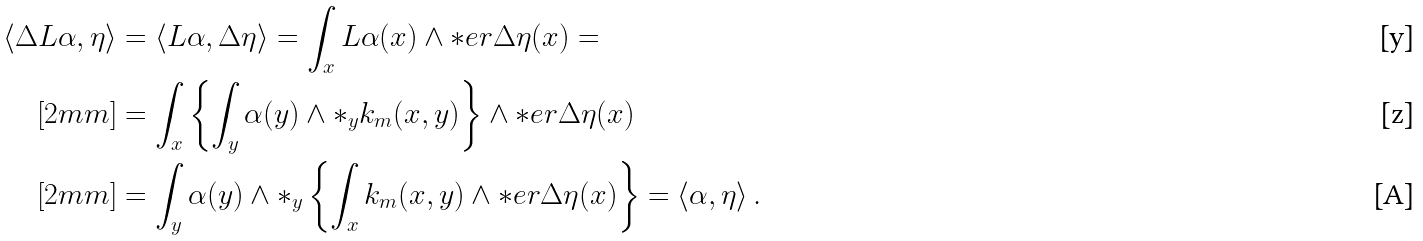<formula> <loc_0><loc_0><loc_500><loc_500>\langle \Delta L \alpha , \eta \rangle & = \langle L \alpha , \Delta \eta \rangle = \int _ { x } L \alpha ( x ) \wedge \ast e r \Delta \eta ( x ) = \\ [ 2 m m ] & = \int _ { x } \left \{ \int _ { y } \alpha ( y ) \wedge * _ { y } k _ { m } ( x , y ) \right \} \wedge \ast e r \Delta \eta ( x ) \\ [ 2 m m ] & = \int _ { y } \alpha ( y ) \wedge * _ { y } \left \{ \int _ { x } k _ { m } ( x , y ) \wedge \ast e r \Delta \eta ( x ) \right \} = \langle \alpha , \eta \rangle \, .</formula> 